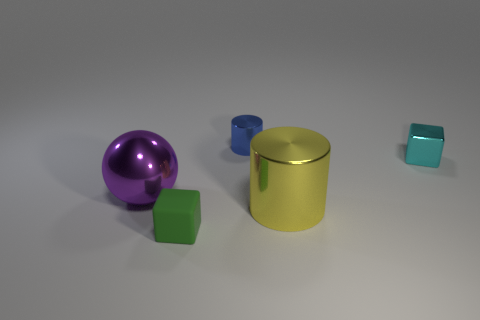Add 3 tiny rubber cubes. How many objects exist? 8 Subtract all cylinders. How many objects are left? 3 Subtract all small matte things. Subtract all large blue cubes. How many objects are left? 4 Add 1 purple balls. How many purple balls are left? 2 Add 1 metallic cylinders. How many metallic cylinders exist? 3 Subtract 1 purple spheres. How many objects are left? 4 